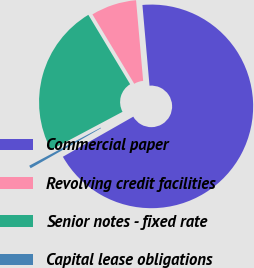<chart> <loc_0><loc_0><loc_500><loc_500><pie_chart><fcel>Commercial paper<fcel>Revolving credit facilities<fcel>Senior notes - fixed rate<fcel>Capital lease obligations<nl><fcel>68.15%<fcel>7.23%<fcel>24.15%<fcel>0.46%<nl></chart> 